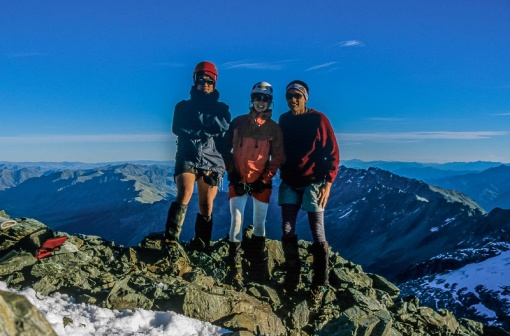Imagine the mountains in the background as gigantic, ancient creatures. What could their story be? Once, long ago, the mountains that now stand tall and silent were mighty, ancient creatures, guardians of the earth. Known as the Terrakins, they were tasked with maintaining the balance of nature, their colossal forms woven into the fabric of the landscape. Each Terrakin was imbued with elemental powers, controlling the forces of the earth, air, and water to protect and nurture the world.

For millennia, the Terrakins roamed the land, guiding rivers, shaping valleys, and summoning winds to disperse seeds and spread life. They communicated with the flora and fauna, ensuring harmony within the ecosystems. However, a great upheaval, caused by clashes between rival elemental forces, threatened to tear the world apart.

To save the earth, the Terrakins made the ultimate sacrifice: they rooted themselves into the ground, transforming their bodies into the very mountains that now dot the landscape. In doing so, they stabilized the world, their elemental energies flowing through the veins of the earth, maintaining balance and fostering life in silent vigilance.

Eons have passed, and the legend of the Terrakins has faded into myth. Yet, some say that on nights when the stars align and the winds whisper ancient secrets, you can hear the heartbeat of the Terrakins resonating within the mountains. It’s a reminder of their eternal watch, echoing the sacrifices they made to safeguard the world they loved. 